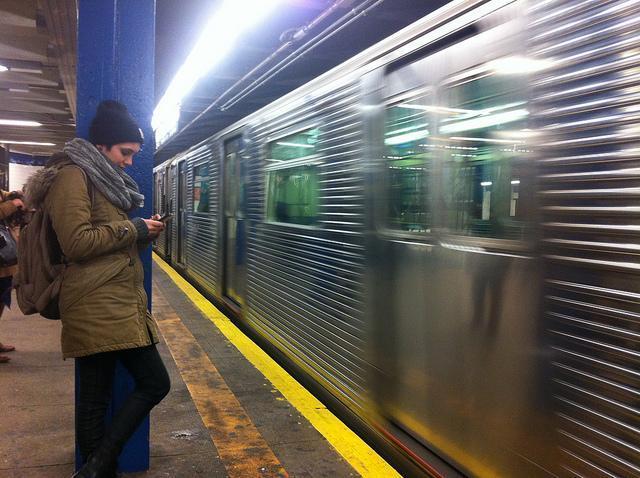How many people are in the picture?
Give a very brief answer. 1. How many trucks are on the road?
Give a very brief answer. 0. 